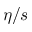Convert formula to latex. <formula><loc_0><loc_0><loc_500><loc_500>\eta / s</formula> 